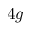Convert formula to latex. <formula><loc_0><loc_0><loc_500><loc_500>4 g</formula> 